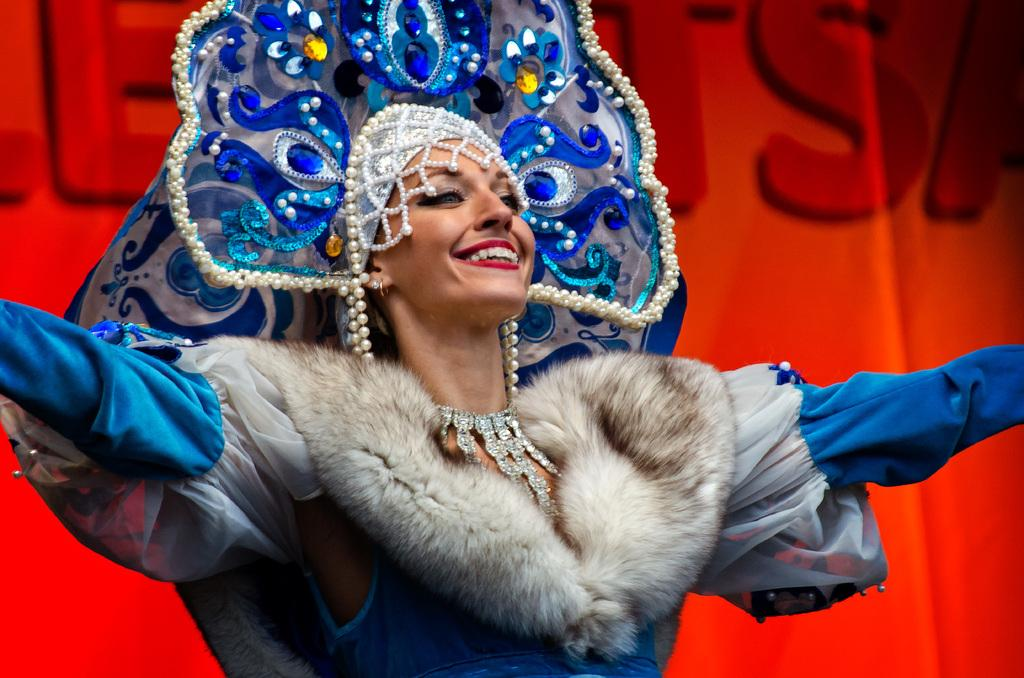Who is present in the image? There is a woman in the image. What is the woman wearing in the image? The woman is wearing a costume and a crown in the image. What type of fowl can be seen in the image? There is no fowl present in the image; it features a woman wearing a costume and a crown. What kind of beast is depicted in the image? There is no beast present in the image; it features a woman wearing a costume and a crown. 